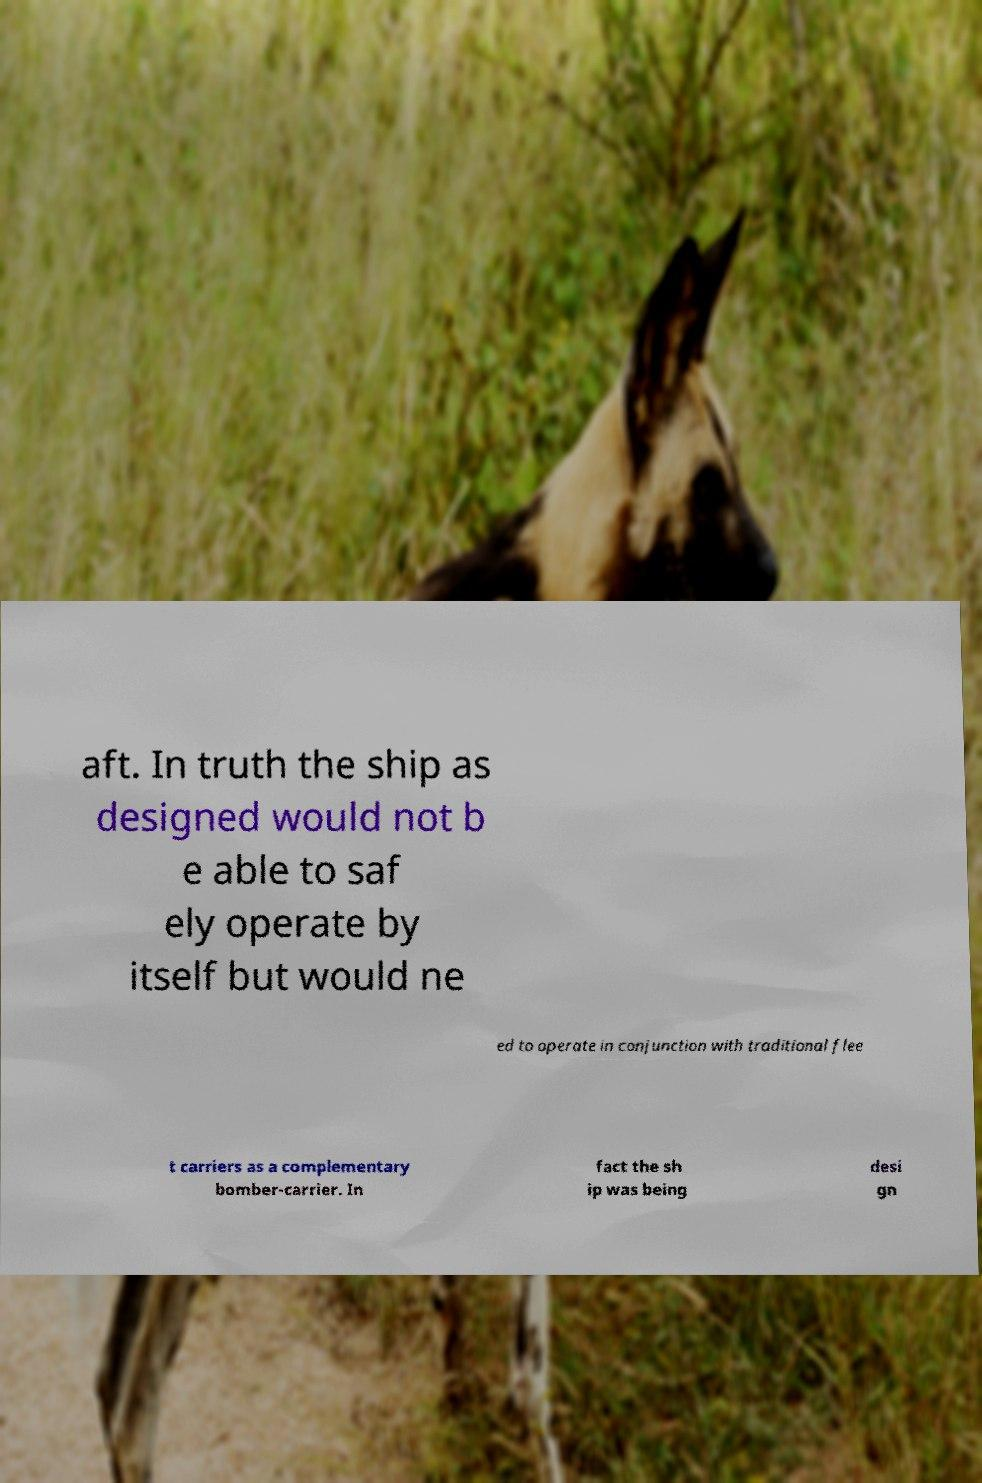I need the written content from this picture converted into text. Can you do that? aft. In truth the ship as designed would not b e able to saf ely operate by itself but would ne ed to operate in conjunction with traditional flee t carriers as a complementary bomber-carrier. In fact the sh ip was being desi gn 